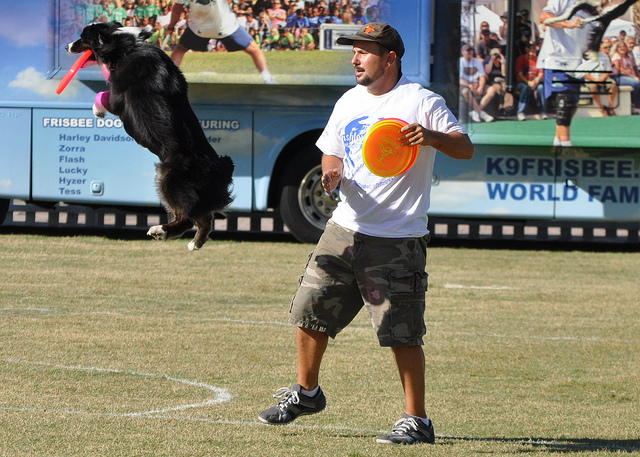Why did the dog jump in the air?
A. flip
B. greet
C. eat
D. catch
Answer with the option's letter from the given choices directly. The correct answer is 'D', catch. The dog jumped in the air to catch the Frisbee thrown by the man. This dynamic action is common in dog sports where dogs are trained to catch flying discs for exercise and entertainment. 